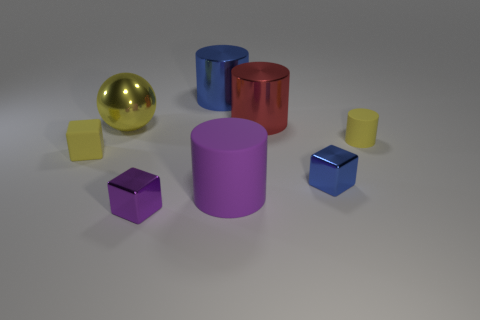What number of objects are small purple shiny cubes or shiny things that are to the right of the large yellow sphere?
Keep it short and to the point. 4. What number of small objects are behind the tiny yellow thing in front of the small thing behind the yellow block?
Provide a succinct answer. 1. There is a purple object that is the same size as the blue cube; what is it made of?
Offer a terse response. Metal. Is there a red metal cylinder that has the same size as the matte cube?
Your answer should be compact. No. What color is the ball?
Offer a terse response. Yellow. There is a big cylinder that is in front of the block left of the small purple block; what color is it?
Your response must be concise. Purple. There is a tiny object that is behind the tiny yellow cube in front of the blue metallic object behind the matte block; what shape is it?
Keep it short and to the point. Cylinder. What number of gray blocks are made of the same material as the tiny blue cube?
Offer a very short reply. 0. How many metallic balls are on the left side of the blue thing in front of the big blue cylinder?
Ensure brevity in your answer.  1. How many small green rubber cylinders are there?
Make the answer very short. 0. 